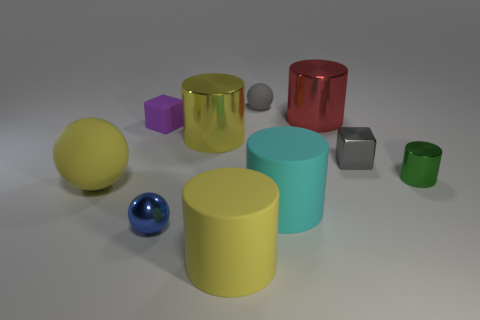Are there more small brown things than gray cubes?
Your response must be concise. No. What is the color of the cube that is on the left side of the small rubber ball?
Provide a succinct answer. Purple. Is the number of shiny objects behind the blue metal ball greater than the number of tiny green metal things?
Offer a terse response. Yes. Does the small green thing have the same material as the red cylinder?
Give a very brief answer. Yes. What number of other objects are the same shape as the cyan rubber thing?
Keep it short and to the point. 4. The small sphere that is on the left side of the ball behind the matte sphere on the left side of the yellow rubber cylinder is what color?
Your answer should be very brief. Blue. There is a large yellow thing left of the small purple block; is its shape the same as the blue shiny object?
Your answer should be compact. Yes. How many small shiny spheres are there?
Provide a succinct answer. 1. How many matte things have the same size as the yellow metallic cylinder?
Give a very brief answer. 3. What is the red object made of?
Your answer should be very brief. Metal. 